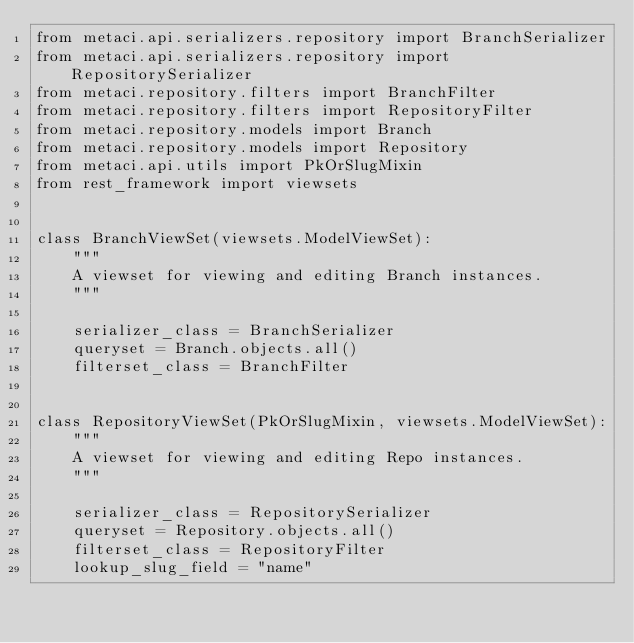Convert code to text. <code><loc_0><loc_0><loc_500><loc_500><_Python_>from metaci.api.serializers.repository import BranchSerializer
from metaci.api.serializers.repository import RepositorySerializer
from metaci.repository.filters import BranchFilter
from metaci.repository.filters import RepositoryFilter
from metaci.repository.models import Branch
from metaci.repository.models import Repository
from metaci.api.utils import PkOrSlugMixin
from rest_framework import viewsets


class BranchViewSet(viewsets.ModelViewSet):
    """
    A viewset for viewing and editing Branch instances.
    """

    serializer_class = BranchSerializer
    queryset = Branch.objects.all()
    filterset_class = BranchFilter


class RepositoryViewSet(PkOrSlugMixin, viewsets.ModelViewSet):
    """
    A viewset for viewing and editing Repo instances.
    """

    serializer_class = RepositorySerializer
    queryset = Repository.objects.all()
    filterset_class = RepositoryFilter
    lookup_slug_field = "name"
</code> 